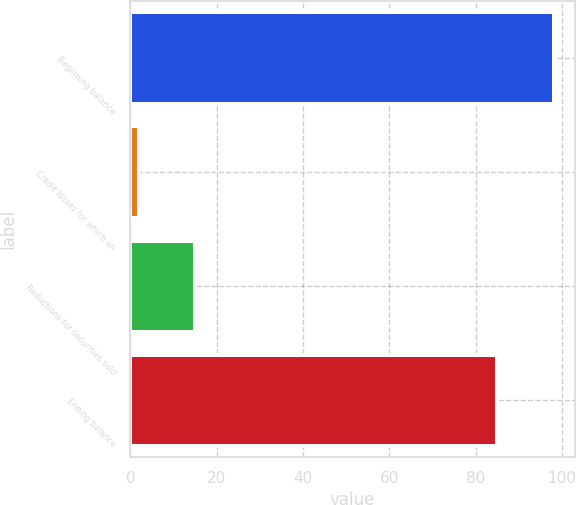<chart> <loc_0><loc_0><loc_500><loc_500><bar_chart><fcel>Beginning balance<fcel>Credit losses for which an<fcel>Reductions for securities sold<fcel>Ending balance<nl><fcel>98<fcel>2<fcel>15<fcel>85<nl></chart> 